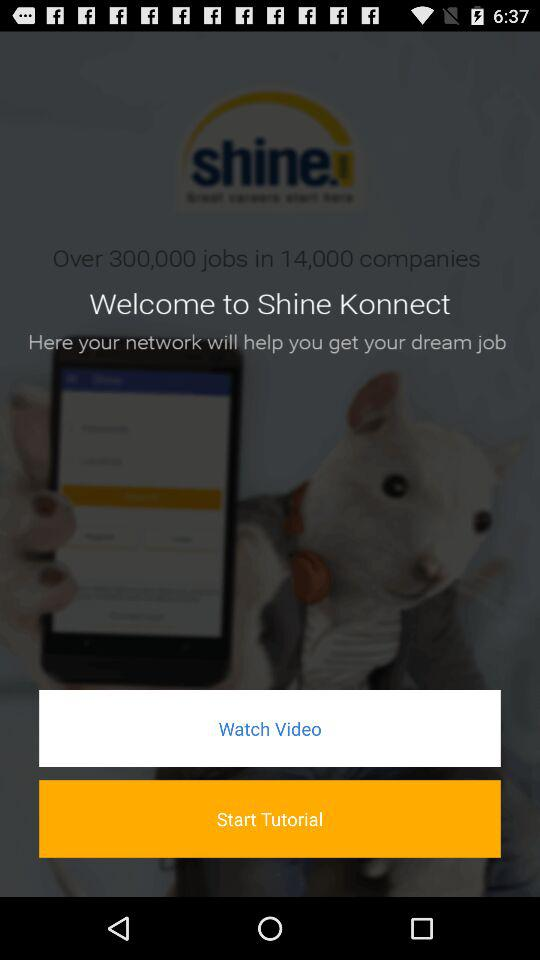What is the name of the application? The name of the application is "Shine Konnect". 